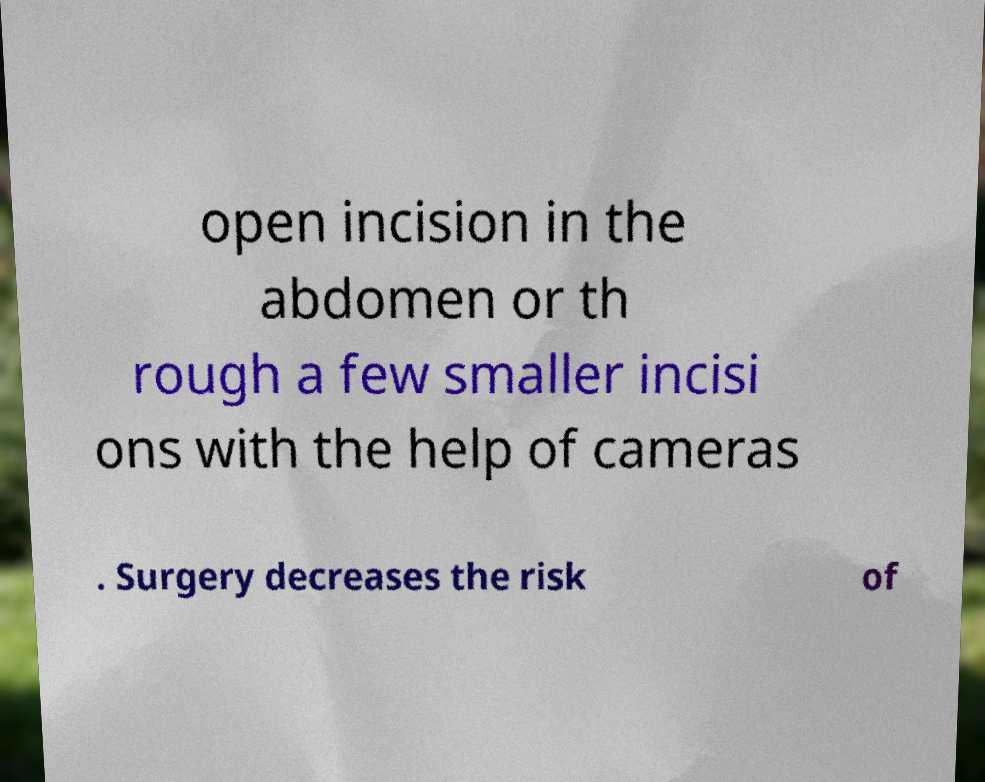Could you extract and type out the text from this image? open incision in the abdomen or th rough a few smaller incisi ons with the help of cameras . Surgery decreases the risk of 